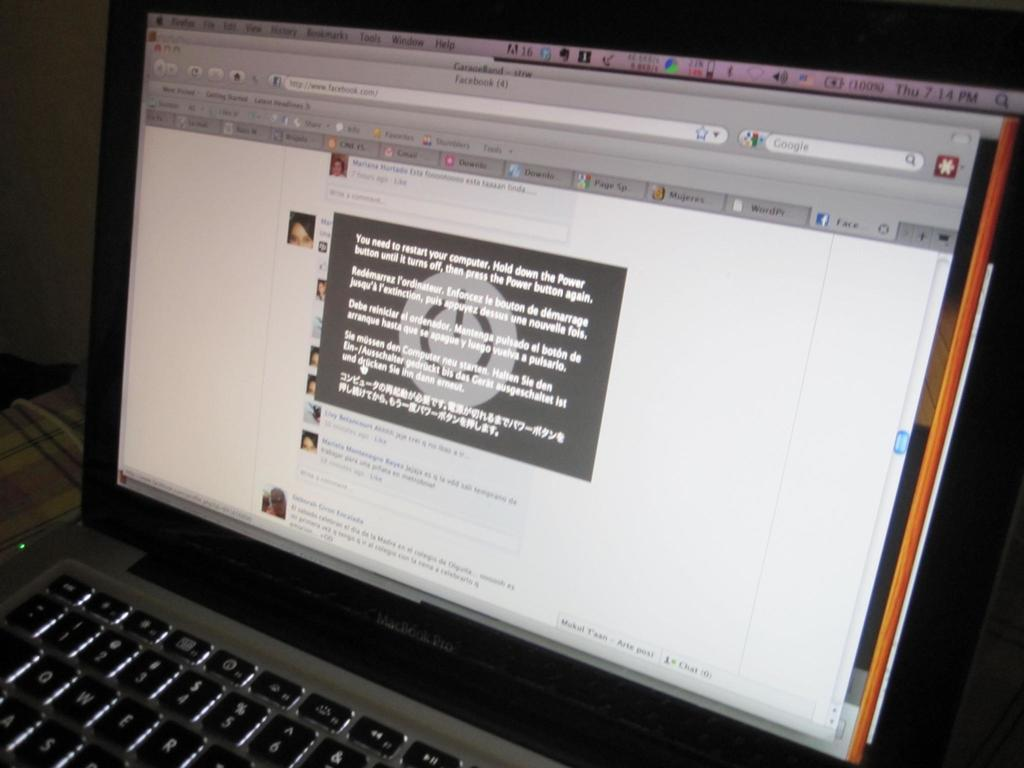<image>
Give a short and clear explanation of the subsequent image. A laptop screen has www.facebook.com in the address bar, but has a popup that says You Need to restart your computer. 